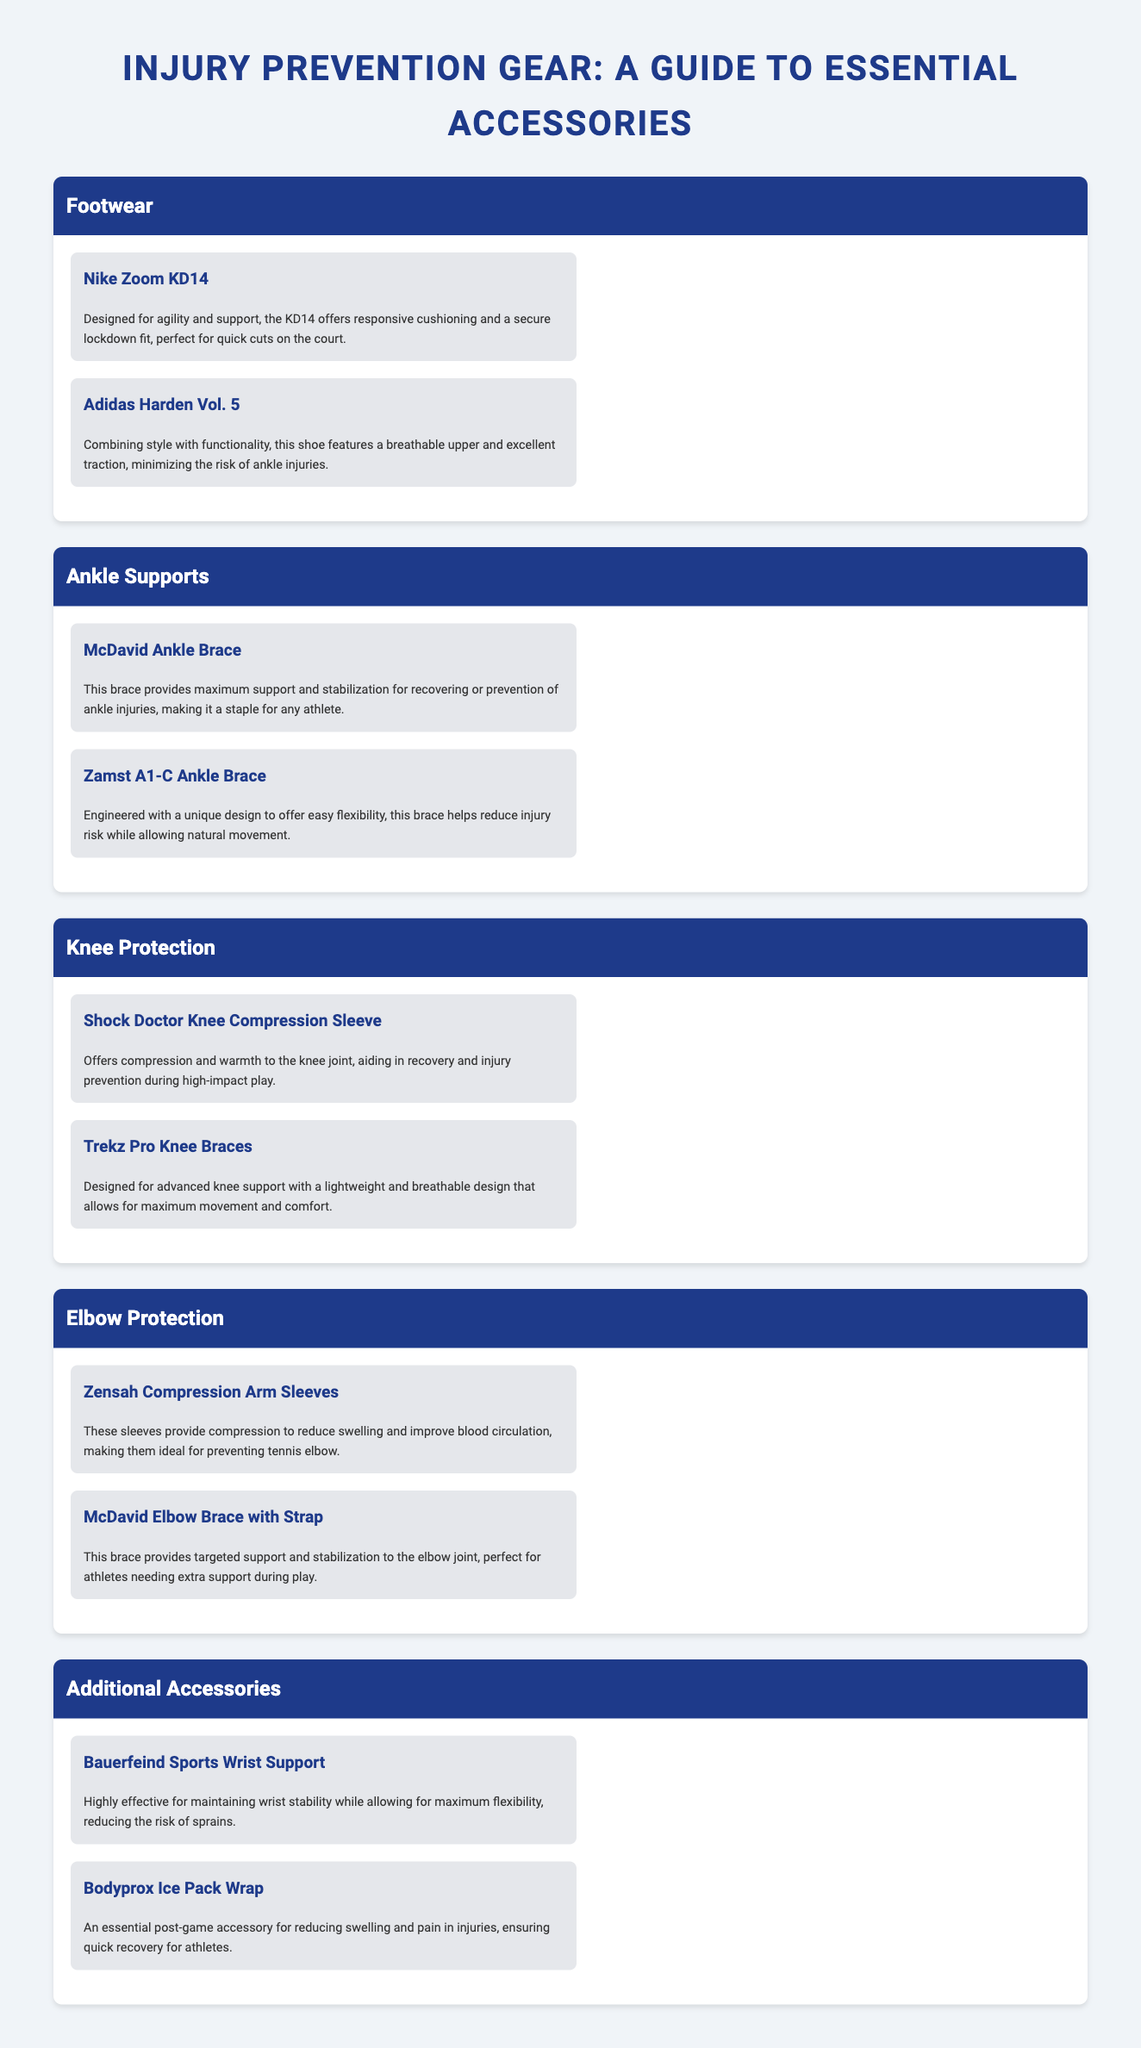What are the names of the two featured footwear options? The footwear options listed are Nike Zoom KD14 and Adidas Harden Vol. 5.
Answer: Nike Zoom KD14, Adidas Harden Vol. 5 What does the McDavid Ankle Brace provide? The McDavid Ankle Brace provides maximum support and stabilization for recovering or prevention of ankle injuries.
Answer: Maximum support and stabilization Which product is designed for advanced knee support? The product designed for advanced knee support is Trekz Pro Knee Braces.
Answer: Trekz Pro Knee Braces How many ankle support options are mentioned? There are two ankle support options mentioned in the document: McDavid Ankle Brace and Zamst A1-C Ankle Brace.
Answer: Two What is the function of Bauerfeind Sports Wrist Support? The Bauerfeind Sports Wrist Support is highly effective for maintaining wrist stability while allowing for maximum flexibility.
Answer: Maintaining wrist stability Which accessory is essential for post-game recovery? The essential post-game accessory for reducing swelling and pain is the Bodyprox Ice Pack Wrap.
Answer: Bodyprox Ice Pack Wrap What type of design does the Zensah Compression Arm Sleeves offer? The Zensah Compression Arm Sleeves provide compression to reduce swelling and improve blood circulation.
Answer: Compression What are the two key benefits of the Adidas Harden Vol. 5? The Adidas Harden Vol. 5 offers a breathable upper and excellent traction.
Answer: Breathable upper, excellent traction 